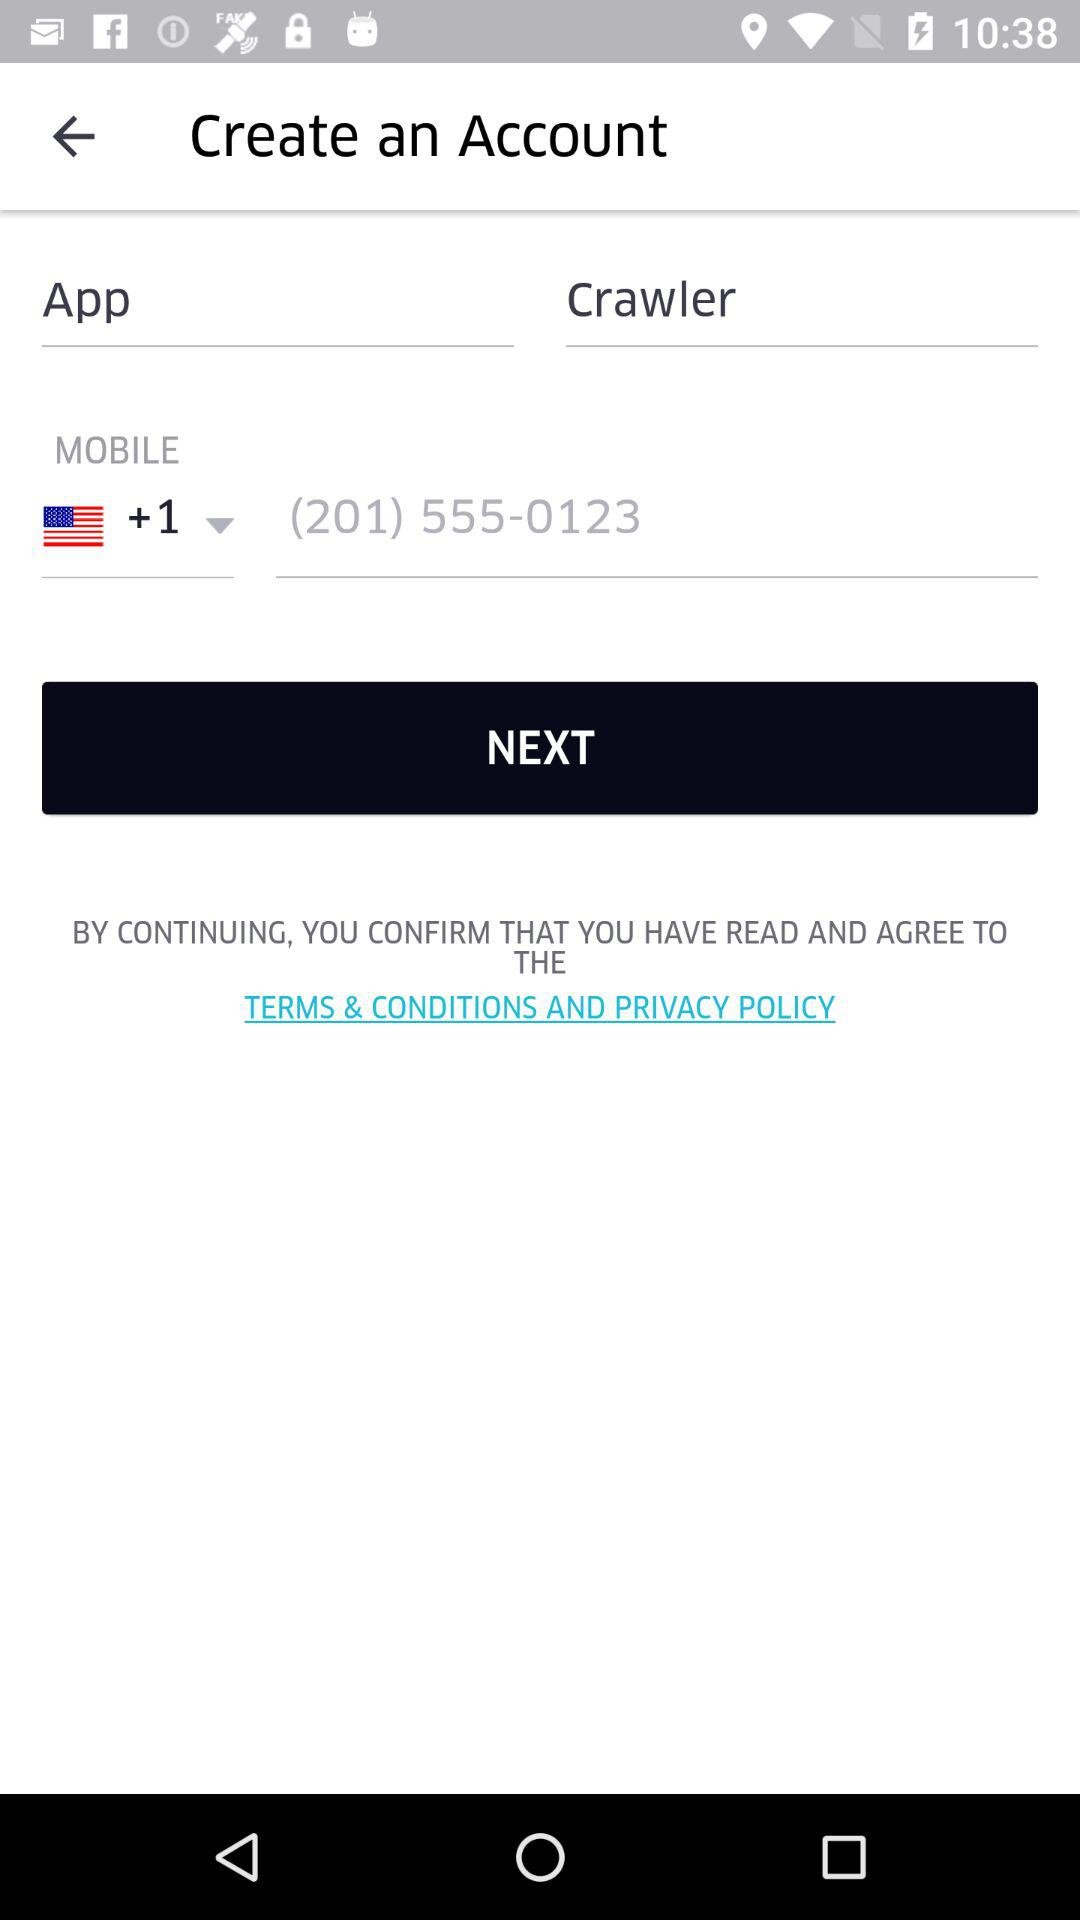Has the user agreed to the terms and conditions and privacy policy?
When the provided information is insufficient, respond with <no answer>. <no answer> 